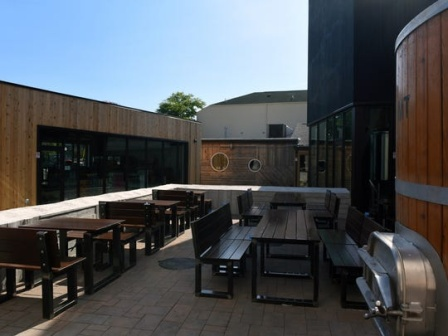How does this brewery patio scene change with the seasons? In the spring, the brewery patio bursts into life with blooming flowers adorning the wooden fence and vibrant green foliage offering a refreshing backdrop. The tables and benches are often occupied by guests enjoying the mild weather and floral scents wafting through the air.

As summer approaches, the patio becomes a lively hub, with longer daylight hours and the sun casting a brilliant glow, making it an ideal spot for enjoying chilled brews under clear blue skies. The area might be dressed up with sun umbrellas and outdoor games to engage the visitors.

Autumn brings a change in hues, with the wooden elements of the patio blending beautifully with the oranges and browns of falling leaves. The brewery might offer seasonal brews like pumpkin ale, and guests can enjoy the crisp air while wrapped in cozy scarves and jackets.

In winter, the patio transforms yet again. While it might be less frequented, it does not lose its charm. The scene is serene, perhaps with a dusting of snow on the tables and benches. Heaters or fire pits could be introduced to provide warmth, creating an inviting space for guests to enjoy warm brews or mulled wine while relishing the quiet beauty of the season. What happens on a quiet weekday morning? On a quiet weekday morning, the brewery patio exudes tranquility. The wooden tables and benches might still be empty, glistening with morning dew. The sun's early rays create a gentle and inviting light, casting soft shadows across the planks. The fermenters stand quietly, awaiting the bustling activity of the brewing process later in the day. There is a peaceful silence, broken only by occasional birds chirping or a gentle breeze rustling through the leaves. It’s a perfect time for a solitary visitor to enjoy a calm moment, perhaps with a hot coffee in hand, reflecting on the serene beauty of the location. 